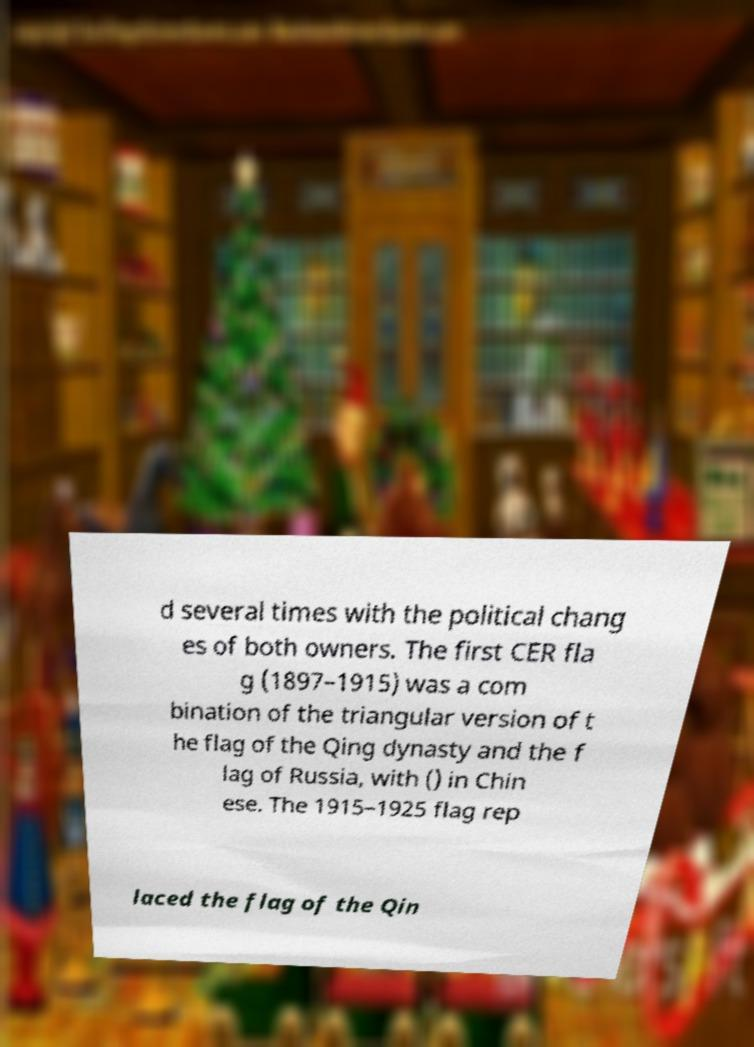Can you read and provide the text displayed in the image?This photo seems to have some interesting text. Can you extract and type it out for me? d several times with the political chang es of both owners. The first CER fla g (1897–1915) was a com bination of the triangular version of t he flag of the Qing dynasty and the f lag of Russia, with () in Chin ese. The 1915–1925 flag rep laced the flag of the Qin 